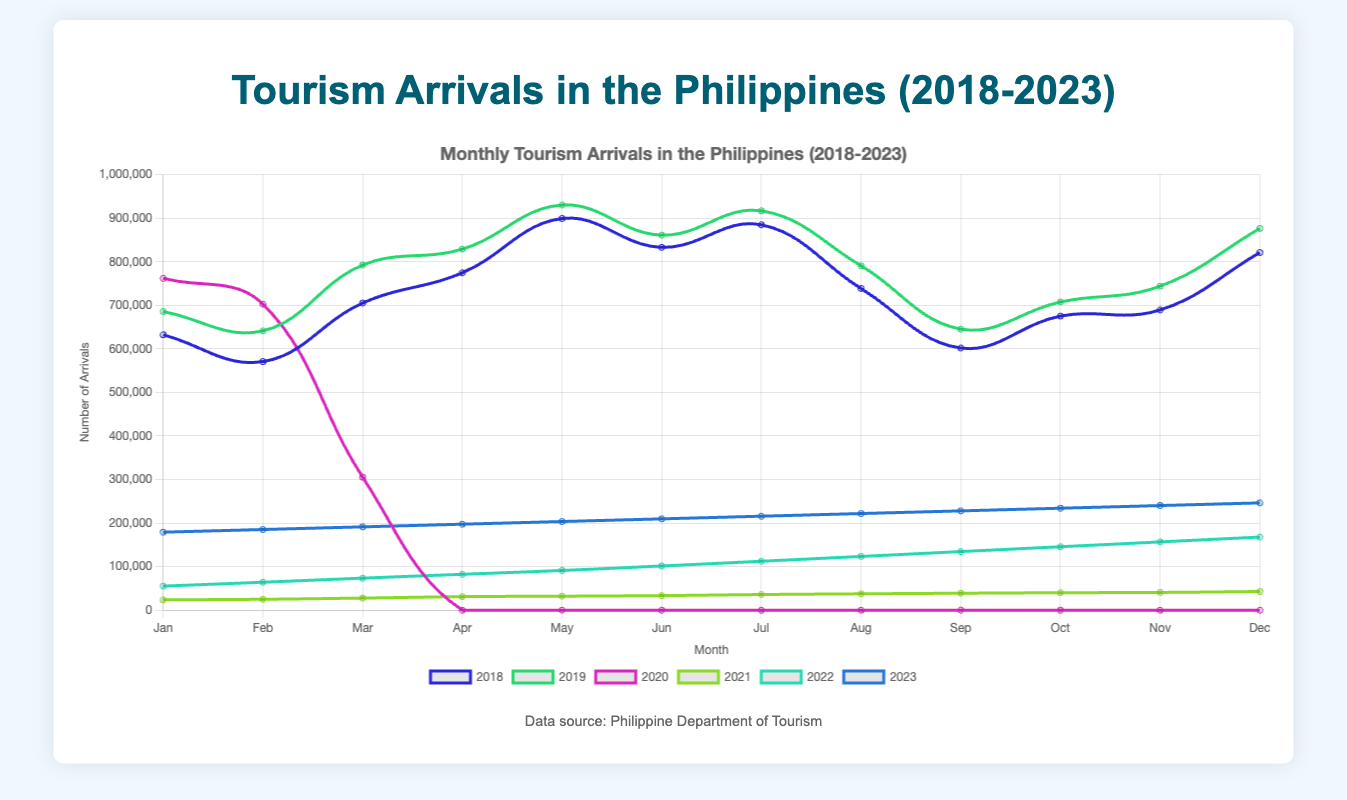Which year had the highest number of arrivals in January? By looking at the graph, observe the line that reaches the highest point in January. Based on the data, the line for the year 2023 reaches the highest point in January with 179,123 arrivals.
Answer: 2023 How did tourism arrivals in March change from 2019 to 2021? To determine this, check the values for March in 2019 and 2021 from the graph. In March 2019, the arrivals were 792,354, while in March 2021, they were 27,836. The change would be calculated as 27,836 - 792,354, showing a significant decrease.
Answer: Decreased by 764,518 Which month in 2020 experienced the lowest number of tourism arrivals? Review the 2020 plot line. All months from April to December showed 0 arrivals, but March had some arrivals before dropping to 0 in April.
Answer: April to December What was the average number of arrivals in 2018? Compute the average by summing the arrivals for each month in 2018 and dividing by 12. The total is 632,293 + 570,709 + 705,141 + 774,513 + 899,216 + 832,989 + 884,736 + 738,566 + 601,896 + 675,177 + 689,295 + 821,124. The sum is 8,825,655, so the average is 8,825,655 / 12.
Answer: 735,471 How did tourism arrivals differ between July 2022 and July 2023? Find and compare the points for July on the lines for 2022 and 2023. In July 2022, arrivals were 112,345 and in July 2023, they were 215,789. The difference is 215,789 - 112,345.
Answer: Increased by 103,444 Which year had the sharpest decline in arrivals between two consecutive months, and during which months did this occur? This involves looking for the steepest negative slope in any yearly line on the graph. Between February and March 2020, the decline is from 702,527 to 305,472.
Answer: 2020, February to March Identify the year when tourism started to significantly recover after 2020 and which month shows this beginning? Look for the gradual increase in tourism arrivals after 2020. The line for 2021 shows a noticeable increase starting from January with 23,789 arrivals and growing steadily.
Answer: 2021, January What is the combined total of arrivals for June and December of 2023? Identify the values for June and December in 2023 from the graph. June has 209,678 and December has 246,344. Adding these gives 209,678 + 246,344.
Answer: 456,022 During which months in 2021 did the tourism arrivals experience the most consistent increase? Check the trend of the line for 2021. It shows a steady rise in arrivals from January (23,789) through December (42,915), with no month showing a decline. The consistent increase is from January to December.
Answer: January to December 